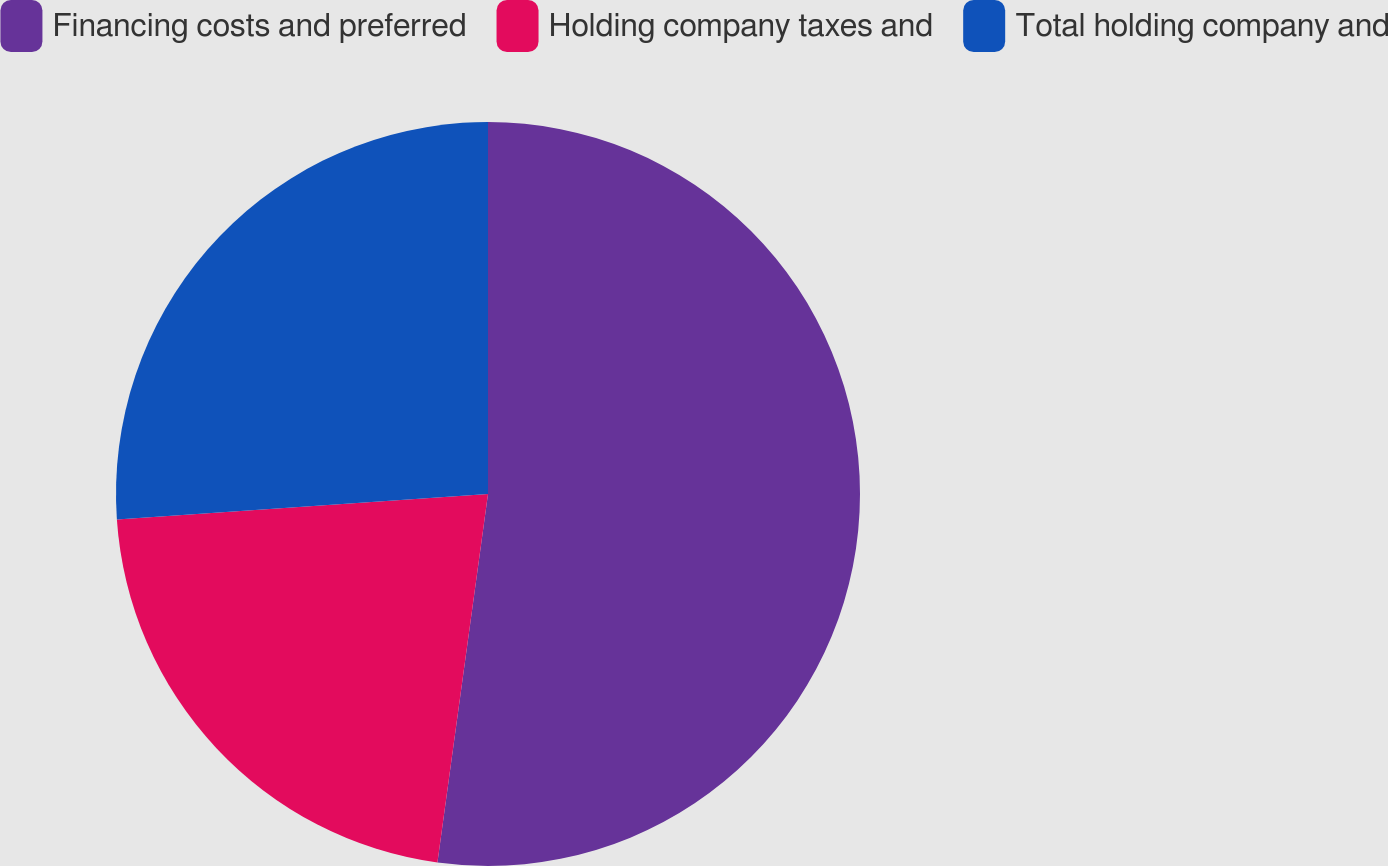Convert chart. <chart><loc_0><loc_0><loc_500><loc_500><pie_chart><fcel>Financing costs and preferred<fcel>Holding company taxes and<fcel>Total holding company and<nl><fcel>52.17%<fcel>21.74%<fcel>26.09%<nl></chart> 